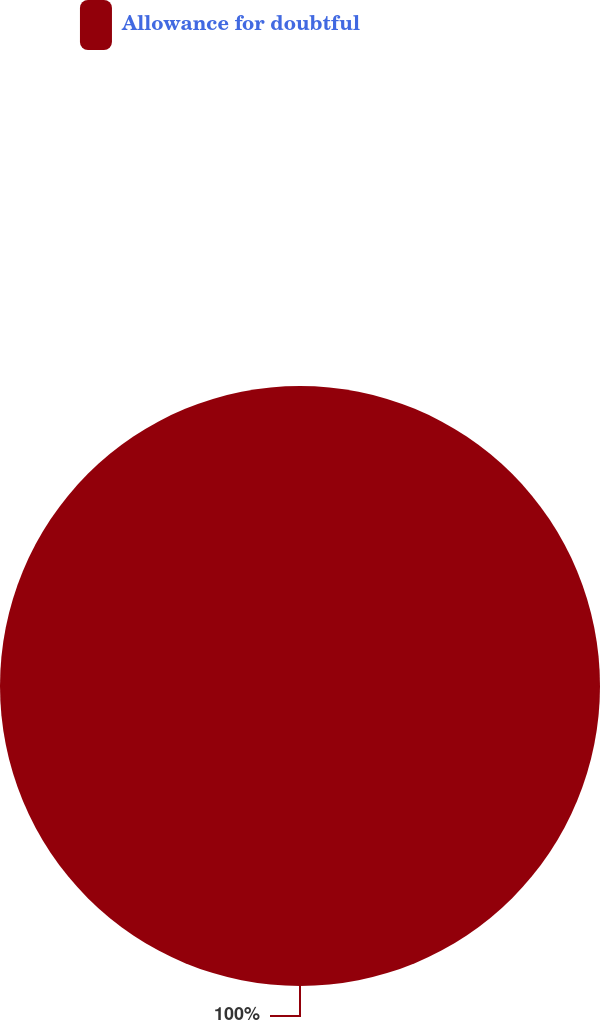Convert chart. <chart><loc_0><loc_0><loc_500><loc_500><pie_chart><fcel>Allowance for doubtful<nl><fcel>100.0%<nl></chart> 